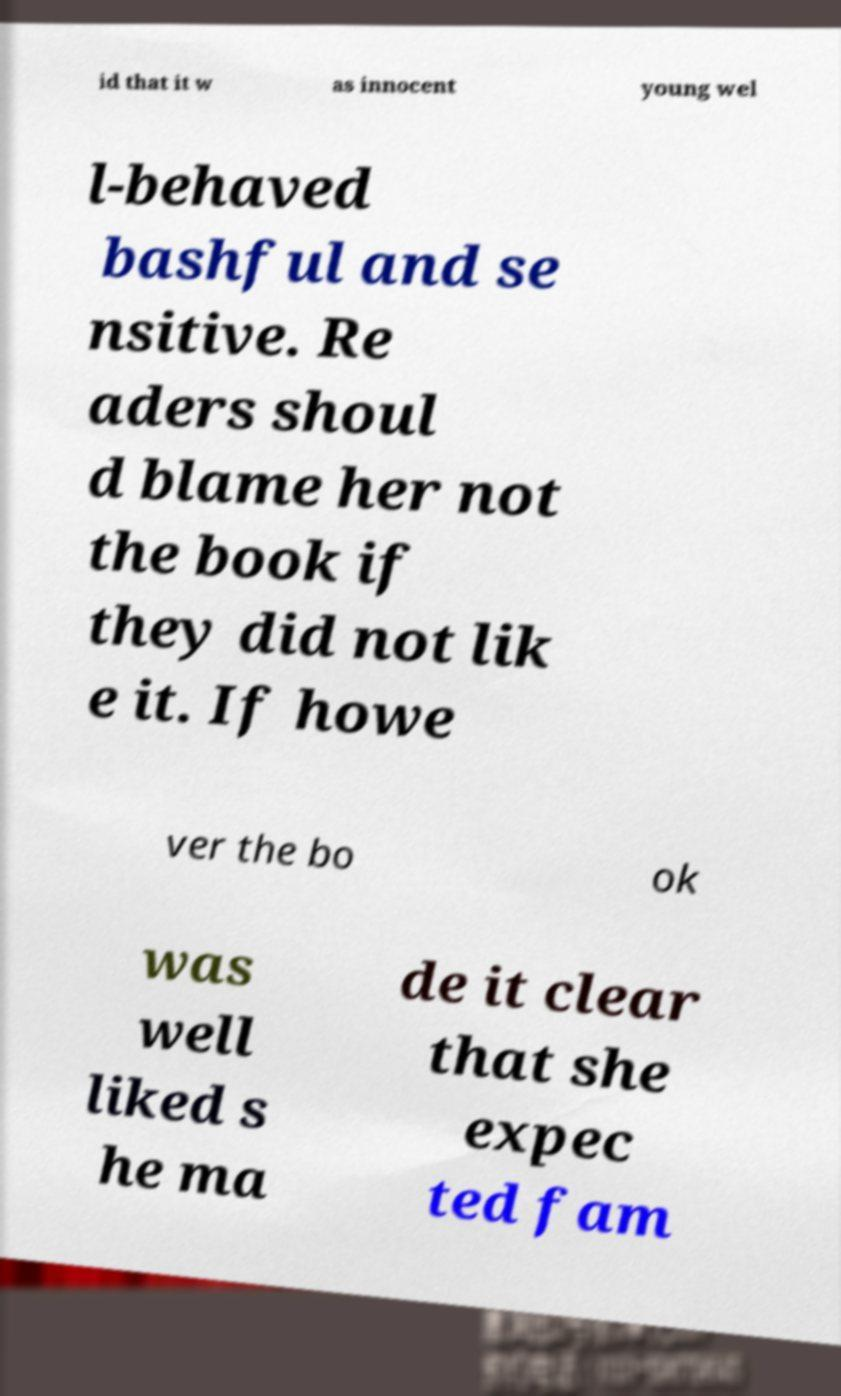What messages or text are displayed in this image? I need them in a readable, typed format. id that it w as innocent young wel l-behaved bashful and se nsitive. Re aders shoul d blame her not the book if they did not lik e it. If howe ver the bo ok was well liked s he ma de it clear that she expec ted fam 